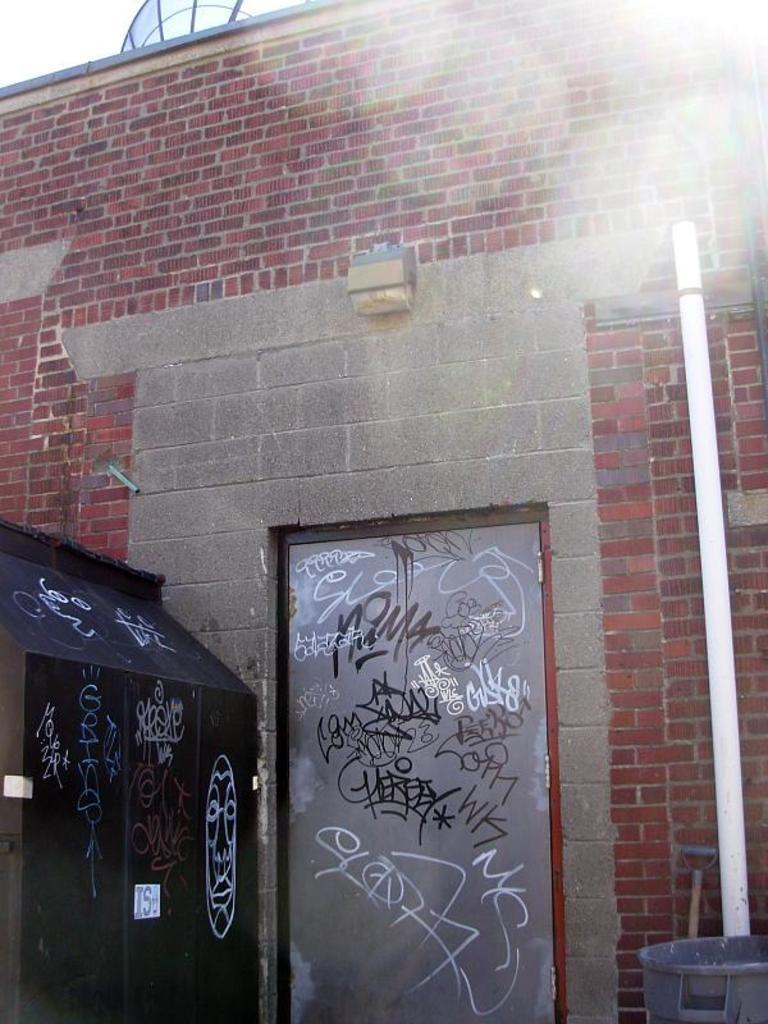In one or two sentences, can you explain what this image depicts? In this picture we can see a wall to which we can see the door, side we can see a box which is black in color. 